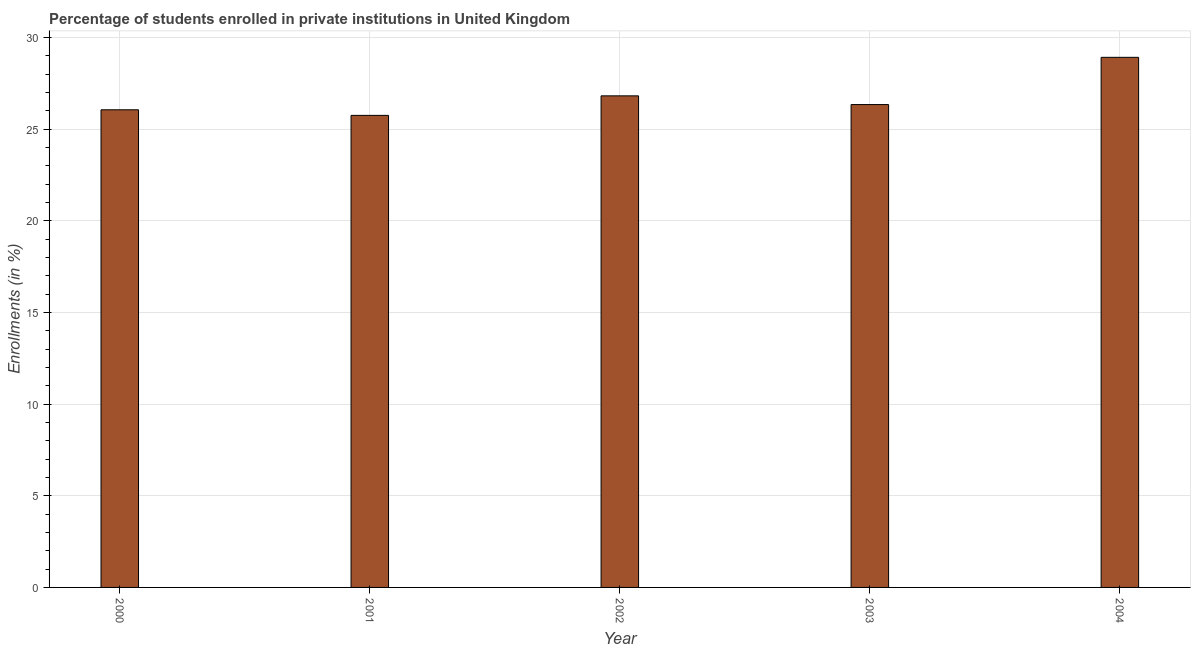Does the graph contain grids?
Give a very brief answer. Yes. What is the title of the graph?
Keep it short and to the point. Percentage of students enrolled in private institutions in United Kingdom. What is the label or title of the X-axis?
Keep it short and to the point. Year. What is the label or title of the Y-axis?
Give a very brief answer. Enrollments (in %). What is the enrollments in private institutions in 2003?
Your answer should be very brief. 26.33. Across all years, what is the maximum enrollments in private institutions?
Offer a terse response. 28.91. Across all years, what is the minimum enrollments in private institutions?
Provide a short and direct response. 25.74. In which year was the enrollments in private institutions minimum?
Your response must be concise. 2001. What is the sum of the enrollments in private institutions?
Your answer should be compact. 133.84. What is the difference between the enrollments in private institutions in 2000 and 2004?
Provide a succinct answer. -2.86. What is the average enrollments in private institutions per year?
Give a very brief answer. 26.77. What is the median enrollments in private institutions?
Provide a succinct answer. 26.33. Do a majority of the years between 2002 and 2003 (inclusive) have enrollments in private institutions greater than 16 %?
Offer a terse response. Yes. What is the ratio of the enrollments in private institutions in 2000 to that in 2001?
Offer a terse response. 1.01. What is the difference between the highest and the second highest enrollments in private institutions?
Your answer should be very brief. 2.1. What is the difference between the highest and the lowest enrollments in private institutions?
Give a very brief answer. 3.17. How many years are there in the graph?
Provide a short and direct response. 5. Are the values on the major ticks of Y-axis written in scientific E-notation?
Keep it short and to the point. No. What is the Enrollments (in %) in 2000?
Keep it short and to the point. 26.05. What is the Enrollments (in %) in 2001?
Provide a succinct answer. 25.74. What is the Enrollments (in %) in 2002?
Provide a short and direct response. 26.81. What is the Enrollments (in %) in 2003?
Give a very brief answer. 26.33. What is the Enrollments (in %) of 2004?
Your answer should be very brief. 28.91. What is the difference between the Enrollments (in %) in 2000 and 2001?
Offer a terse response. 0.31. What is the difference between the Enrollments (in %) in 2000 and 2002?
Your answer should be compact. -0.76. What is the difference between the Enrollments (in %) in 2000 and 2003?
Provide a short and direct response. -0.28. What is the difference between the Enrollments (in %) in 2000 and 2004?
Offer a terse response. -2.86. What is the difference between the Enrollments (in %) in 2001 and 2002?
Your answer should be very brief. -1.07. What is the difference between the Enrollments (in %) in 2001 and 2003?
Provide a short and direct response. -0.59. What is the difference between the Enrollments (in %) in 2001 and 2004?
Provide a succinct answer. -3.17. What is the difference between the Enrollments (in %) in 2002 and 2003?
Your answer should be very brief. 0.48. What is the difference between the Enrollments (in %) in 2002 and 2004?
Ensure brevity in your answer.  -2.1. What is the difference between the Enrollments (in %) in 2003 and 2004?
Your answer should be very brief. -2.58. What is the ratio of the Enrollments (in %) in 2000 to that in 2001?
Offer a very short reply. 1.01. What is the ratio of the Enrollments (in %) in 2000 to that in 2004?
Keep it short and to the point. 0.9. What is the ratio of the Enrollments (in %) in 2001 to that in 2003?
Keep it short and to the point. 0.98. What is the ratio of the Enrollments (in %) in 2001 to that in 2004?
Provide a short and direct response. 0.89. What is the ratio of the Enrollments (in %) in 2002 to that in 2003?
Provide a short and direct response. 1.02. What is the ratio of the Enrollments (in %) in 2002 to that in 2004?
Ensure brevity in your answer.  0.93. What is the ratio of the Enrollments (in %) in 2003 to that in 2004?
Your response must be concise. 0.91. 